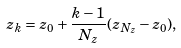Convert formula to latex. <formula><loc_0><loc_0><loc_500><loc_500>z _ { k } = z _ { 0 } + \frac { k - 1 } { N _ { z } } ( z _ { N _ { z } } - z _ { 0 } ) ,</formula> 